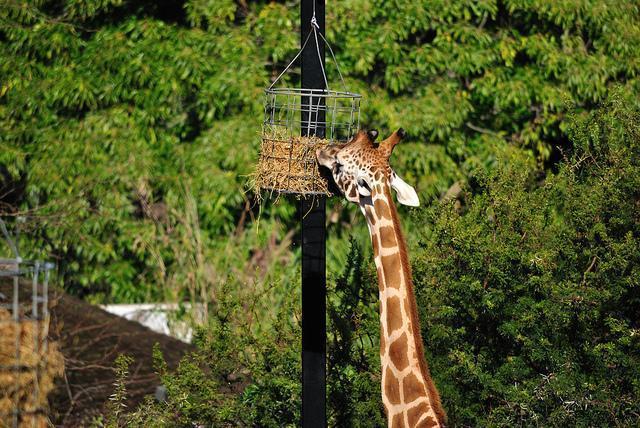How many giraffes are facing the camera?
Give a very brief answer. 0. How many red color people are there in the image ?ok?
Give a very brief answer. 0. 